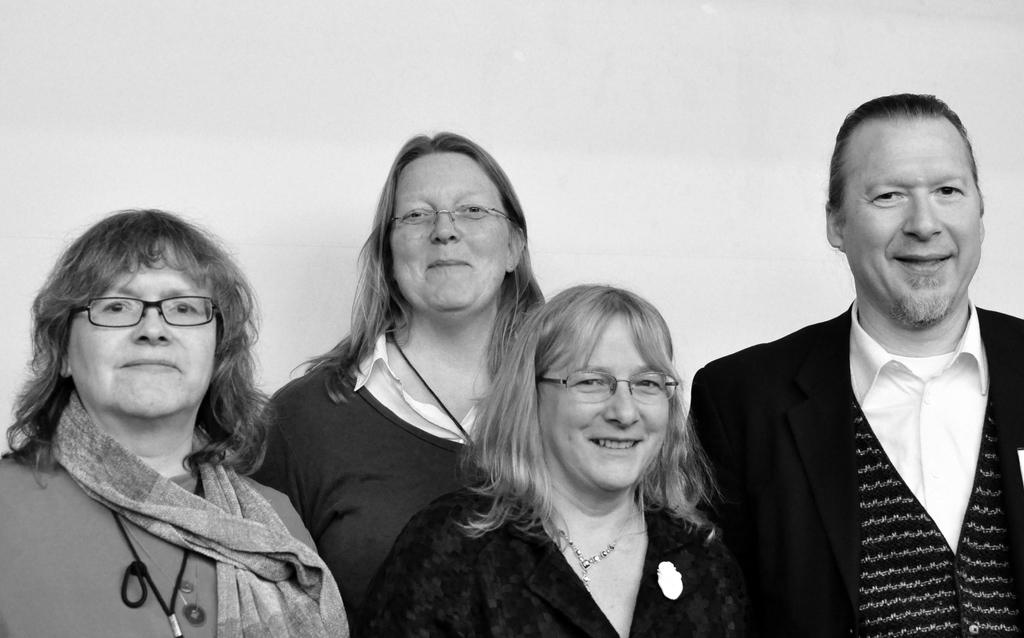How many people are wearing dresses in the image? There are four people with dresses in the image. How many people are wearing specs in the image? There are three people with specs in the image. What can be seen in the background of the image? There is a wall in the background of the image. What is the color scheme of the image? The image is black and white. What type of soup is being served in the image? There is no soup present in the image; it is a black and white image featuring people with dresses and specs in front of a wall. 